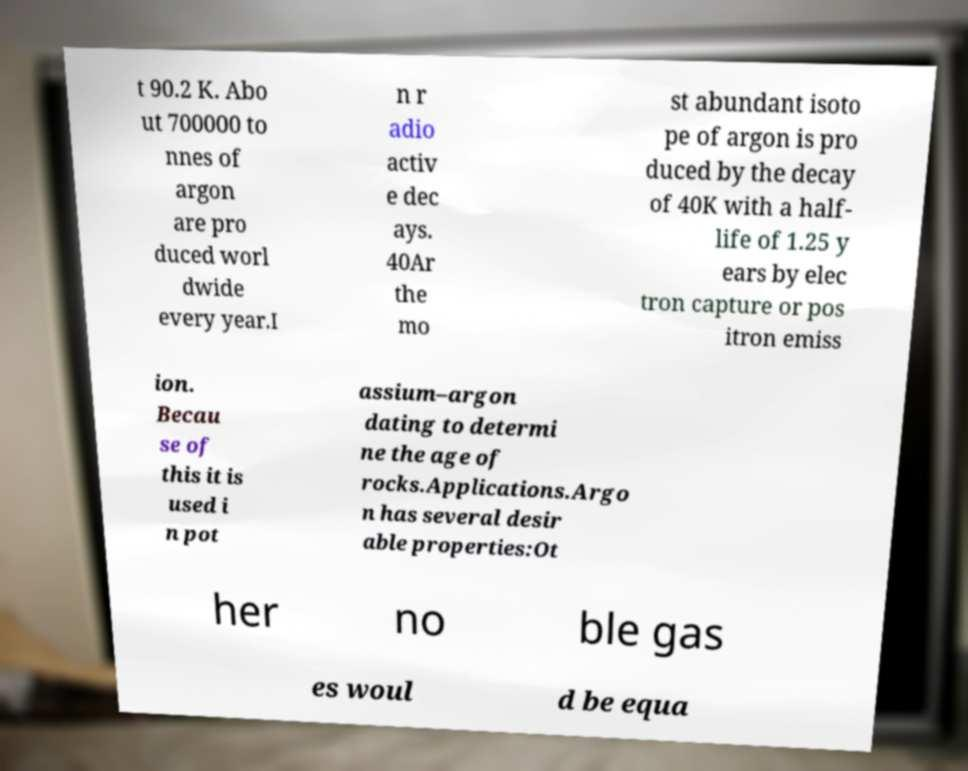Please identify and transcribe the text found in this image. t 90.2 K. Abo ut 700000 to nnes of argon are pro duced worl dwide every year.I n r adio activ e dec ays. 40Ar the mo st abundant isoto pe of argon is pro duced by the decay of 40K with a half- life of 1.25 y ears by elec tron capture or pos itron emiss ion. Becau se of this it is used i n pot assium–argon dating to determi ne the age of rocks.Applications.Argo n has several desir able properties:Ot her no ble gas es woul d be equa 